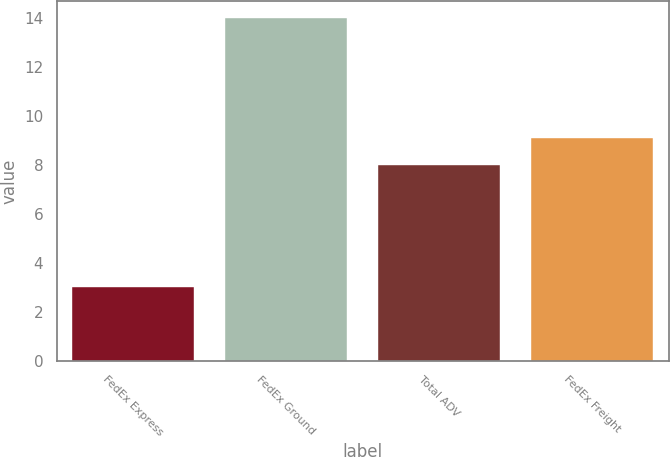<chart> <loc_0><loc_0><loc_500><loc_500><bar_chart><fcel>FedEx Express<fcel>FedEx Ground<fcel>Total ADV<fcel>FedEx Freight<nl><fcel>3<fcel>14<fcel>8<fcel>9.1<nl></chart> 